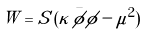<formula> <loc_0><loc_0><loc_500><loc_500>W = S \, ( \kappa \, \bar { \phi } \phi - \mu ^ { 2 } )</formula> 